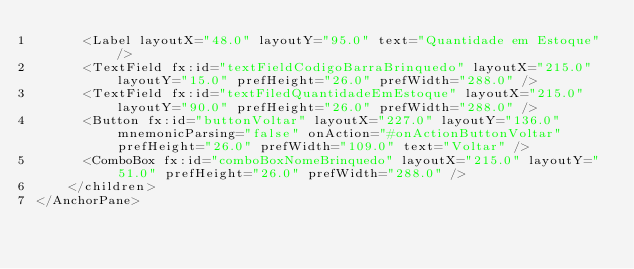Convert code to text. <code><loc_0><loc_0><loc_500><loc_500><_XML_>      <Label layoutX="48.0" layoutY="95.0" text="Quantidade em Estoque" />
      <TextField fx:id="textFieldCodigoBarraBrinquedo" layoutX="215.0" layoutY="15.0" prefHeight="26.0" prefWidth="288.0" />
      <TextField fx:id="textFiledQuantidadeEmEstoque" layoutX="215.0" layoutY="90.0" prefHeight="26.0" prefWidth="288.0" />
      <Button fx:id="buttonVoltar" layoutX="227.0" layoutY="136.0" mnemonicParsing="false" onAction="#onActionButtonVoltar" prefHeight="26.0" prefWidth="109.0" text="Voltar" />
      <ComboBox fx:id="comboBoxNomeBrinquedo" layoutX="215.0" layoutY="51.0" prefHeight="26.0" prefWidth="288.0" />
    </children>
</AnchorPane>
</code> 